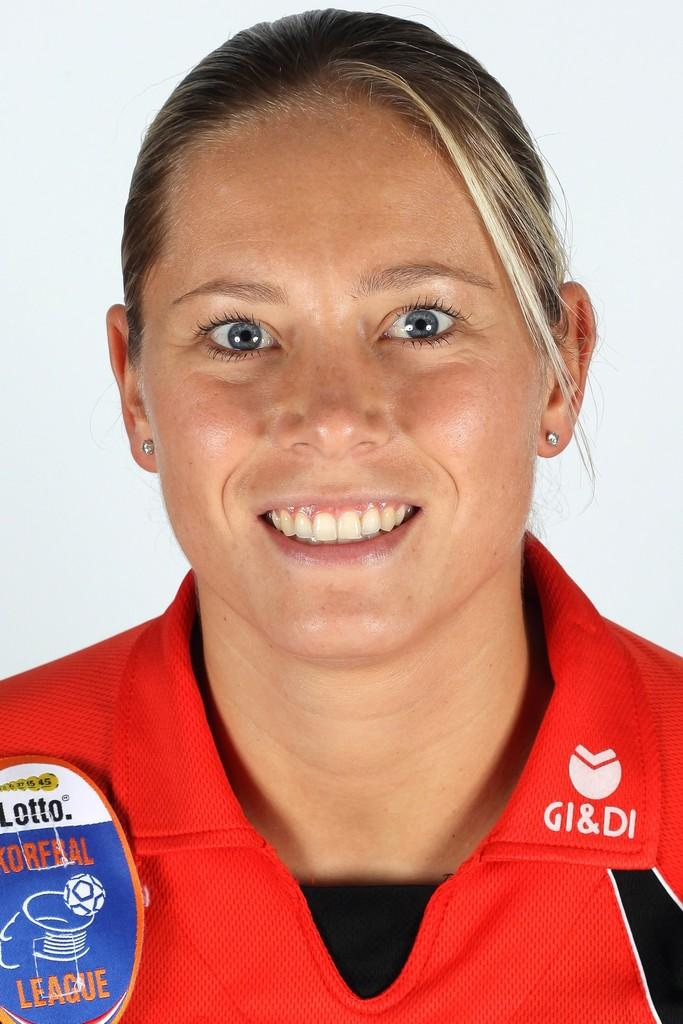Provide a one-sentence caption for the provided image. A smiling blond woman with blue eyes wearing a red jersey for the Korfbal Leauge. 